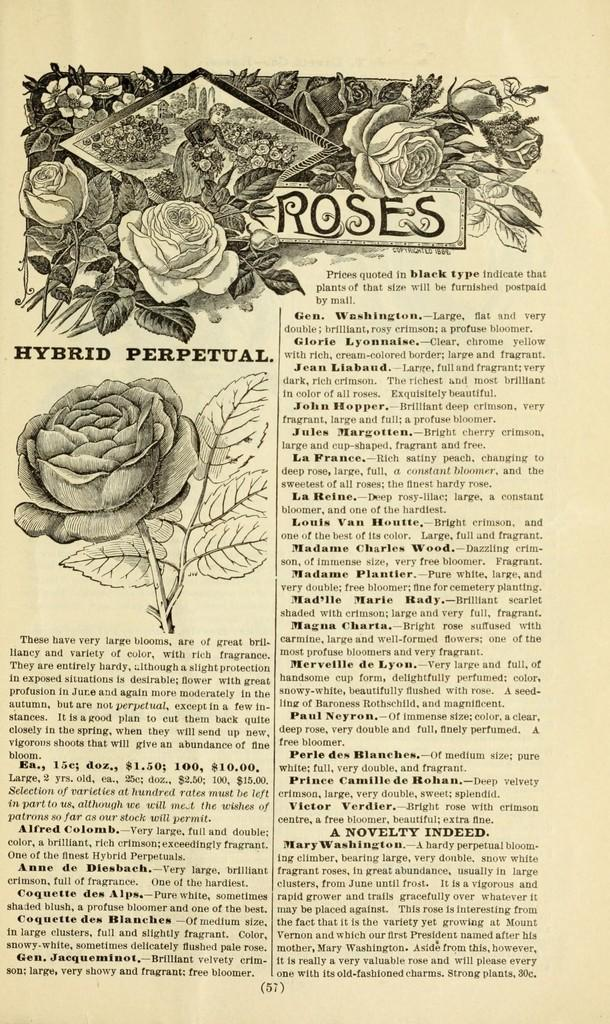What is present on the paper in the image? There is text written on the paper, as well as roses and a person's picture drawn on it. Can you describe the text on the paper? Unfortunately, the specific content of the text cannot be determined from the image. What type of drawing is present on the paper? There are roses and a person's picture drawn on the paper. What type of spade is being used to dig in the image? There is no spade present in the image; it only features a paper with text, roses, and a person's picture drawn on it. 